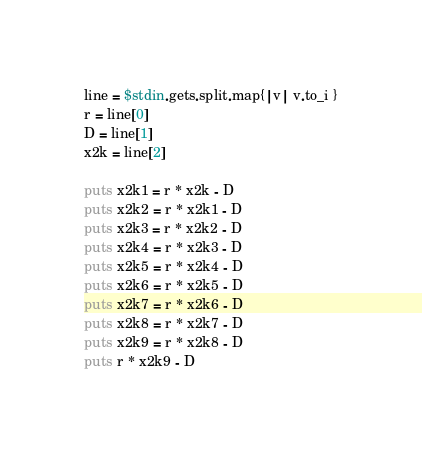Convert code to text. <code><loc_0><loc_0><loc_500><loc_500><_Ruby_>line = $stdin.gets.split.map{|v| v.to_i }
r = line[0]
D = line[1]
x2k = line[2]

puts x2k1 = r * x2k - D
puts x2k2 = r * x2k1 - D
puts x2k3 = r * x2k2 - D
puts x2k4 = r * x2k3 - D
puts x2k5 = r * x2k4 - D
puts x2k6 = r * x2k5 - D
puts x2k7 = r * x2k6 - D
puts x2k8 = r * x2k7 - D
puts x2k9 = r * x2k8 - D
puts r * x2k9 - D
</code> 